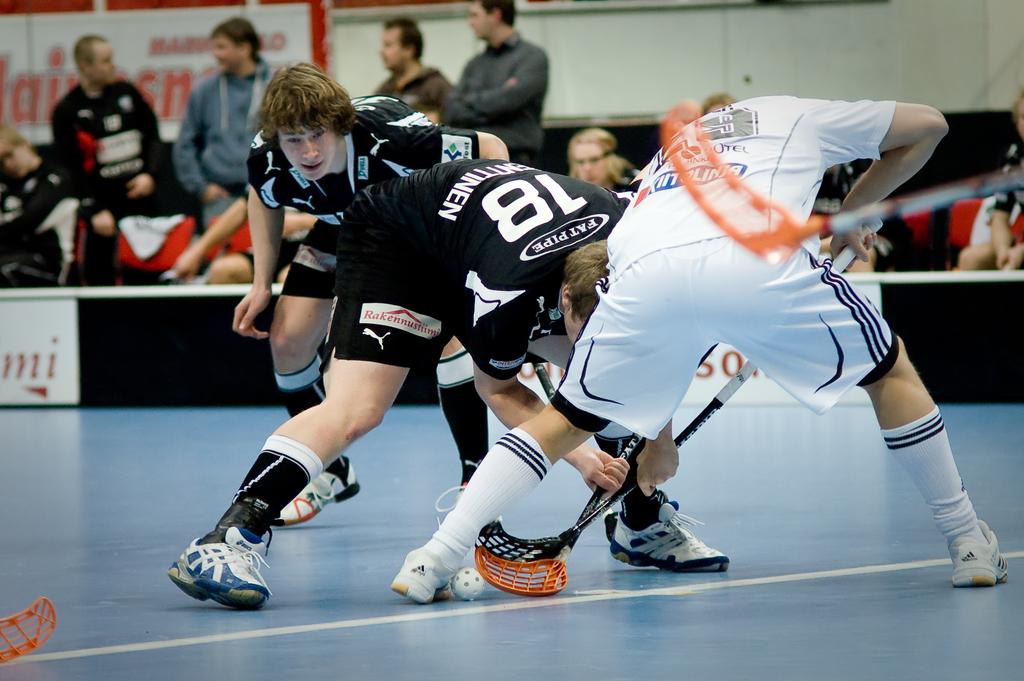Do the players in black play for fatpipe?
Your answer should be compact. Yes. 